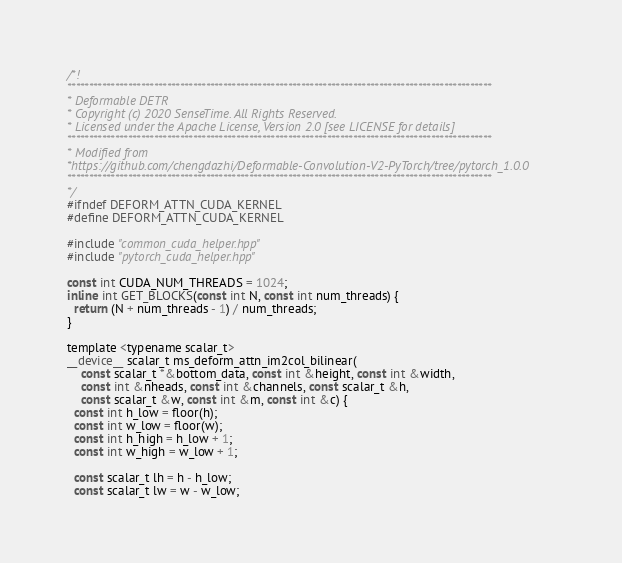Convert code to text. <code><loc_0><loc_0><loc_500><loc_500><_Cuda_>/*!
**************************************************************************************************
* Deformable DETR
* Copyright (c) 2020 SenseTime. All Rights Reserved.
* Licensed under the Apache License, Version 2.0 [see LICENSE for details]
**************************************************************************************************
* Modified from
*https://github.com/chengdazhi/Deformable-Convolution-V2-PyTorch/tree/pytorch_1.0.0
**************************************************************************************************
*/
#ifndef DEFORM_ATTN_CUDA_KERNEL
#define DEFORM_ATTN_CUDA_KERNEL

#include "common_cuda_helper.hpp"
#include "pytorch_cuda_helper.hpp"

const int CUDA_NUM_THREADS = 1024;
inline int GET_BLOCKS(const int N, const int num_threads) {
  return (N + num_threads - 1) / num_threads;
}

template <typename scalar_t>
__device__ scalar_t ms_deform_attn_im2col_bilinear(
    const scalar_t *&bottom_data, const int &height, const int &width,
    const int &nheads, const int &channels, const scalar_t &h,
    const scalar_t &w, const int &m, const int &c) {
  const int h_low = floor(h);
  const int w_low = floor(w);
  const int h_high = h_low + 1;
  const int w_high = w_low + 1;

  const scalar_t lh = h - h_low;
  const scalar_t lw = w - w_low;</code> 